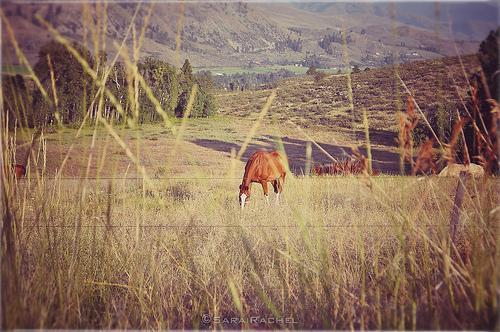How many horses eating?
Give a very brief answer. 1. 